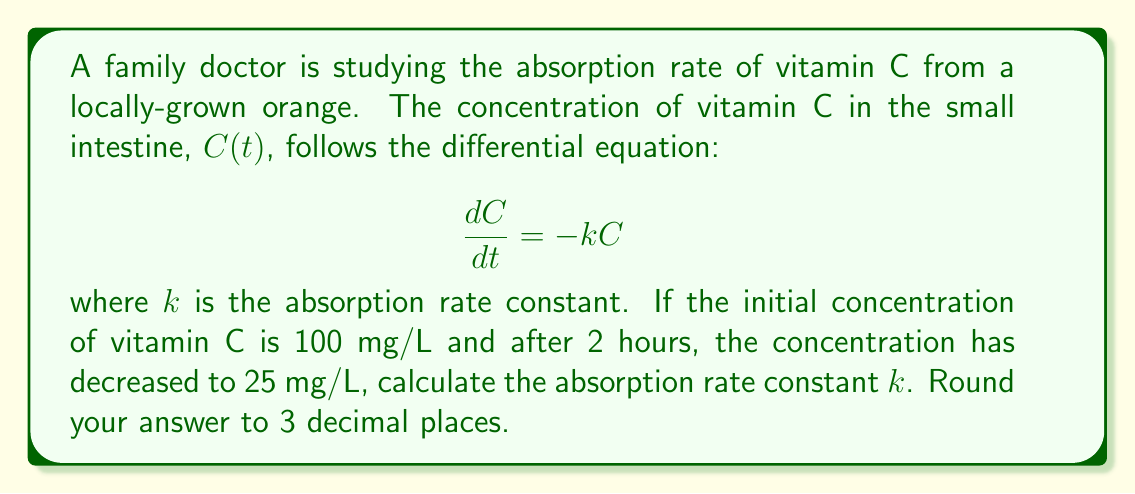Help me with this question. To solve this problem, we'll follow these steps:

1) The given differential equation is a first-order linear equation:

   $$\frac{dC}{dt} = -kC$$

2) The solution to this equation is an exponential decay function:

   $$C(t) = C_0e^{-kt}$$

   where $C_0$ is the initial concentration.

3) We're given that:
   - $C_0 = 100$ mg/L
   - At $t = 2$ hours, $C(2) = 25$ mg/L

4) Let's substitute these values into our solution:

   $$25 = 100e^{-k(2)}$$

5) Divide both sides by 100:

   $$0.25 = e^{-2k}$$

6) Take the natural logarithm of both sides:

   $$\ln(0.25) = -2k$$

7) Solve for $k$:

   $$k = -\frac{\ln(0.25)}{2}$$

8) Calculate the value:

   $$k = -\frac{\ln(0.25)}{2} = \frac{1.386}{2} = 0.693$$

9) Rounding to 3 decimal places:

   $$k \approx 0.693$$
Answer: $k \approx 0.693$ hour$^{-1}$ 